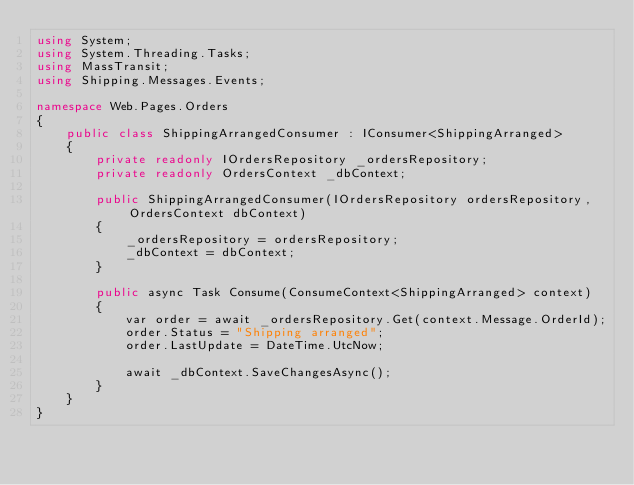<code> <loc_0><loc_0><loc_500><loc_500><_C#_>using System;
using System.Threading.Tasks;
using MassTransit;
using Shipping.Messages.Events;

namespace Web.Pages.Orders
{
    public class ShippingArrangedConsumer : IConsumer<ShippingArranged>
    {
        private readonly IOrdersRepository _ordersRepository;
        private readonly OrdersContext _dbContext;

        public ShippingArrangedConsumer(IOrdersRepository ordersRepository, OrdersContext dbContext)
        {
            _ordersRepository = ordersRepository;
            _dbContext = dbContext;
        }

        public async Task Consume(ConsumeContext<ShippingArranged> context)
        {
            var order = await _ordersRepository.Get(context.Message.OrderId);
            order.Status = "Shipping arranged";
            order.LastUpdate = DateTime.UtcNow;

            await _dbContext.SaveChangesAsync();
        }
    }
}</code> 